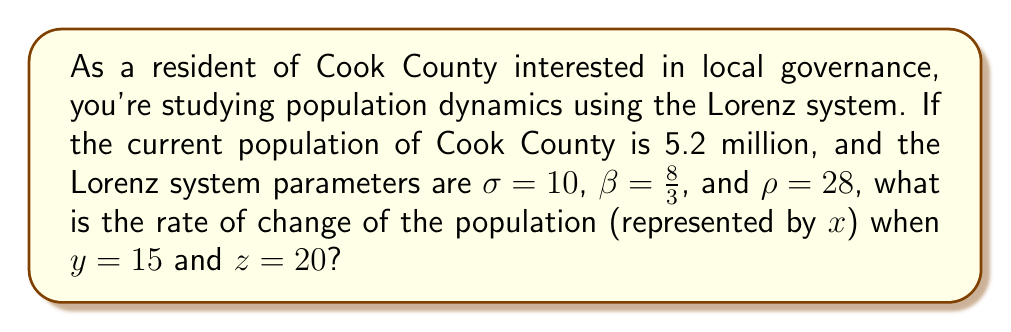Help me with this question. To solve this problem, we'll use the Lorenz system of equations:

1) The Lorenz system is defined by three differential equations:
   $$\frac{dx}{dt} = \sigma(y - x)$$
   $$\frac{dy}{dt} = x(\rho - z) - y$$
   $$\frac{dz}{dt} = xy - \beta z$$

2) We're interested in $\frac{dx}{dt}$, which represents the rate of change of the population.

3) We're given:
   $\sigma = 10$
   $y = 15$
   $x = 5.2$ (million)

4) Plugging these values into the first equation:
   $$\frac{dx}{dt} = \sigma(y - x)$$
   $$\frac{dx}{dt} = 10(15 - 5.2)$$

5) Simplify:
   $$\frac{dx}{dt} = 10(9.8)$$
   $$\frac{dx}{dt} = 98$$

6) Therefore, the rate of change of the population is 98 million people per time unit.

Note: The Lorenz system typically doesn't use real-world units, so the result should be interpreted as a relative rate of change rather than an actual population growth rate.
Answer: 98 million per time unit 